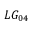<formula> <loc_0><loc_0><loc_500><loc_500>L G _ { 0 4 }</formula> 